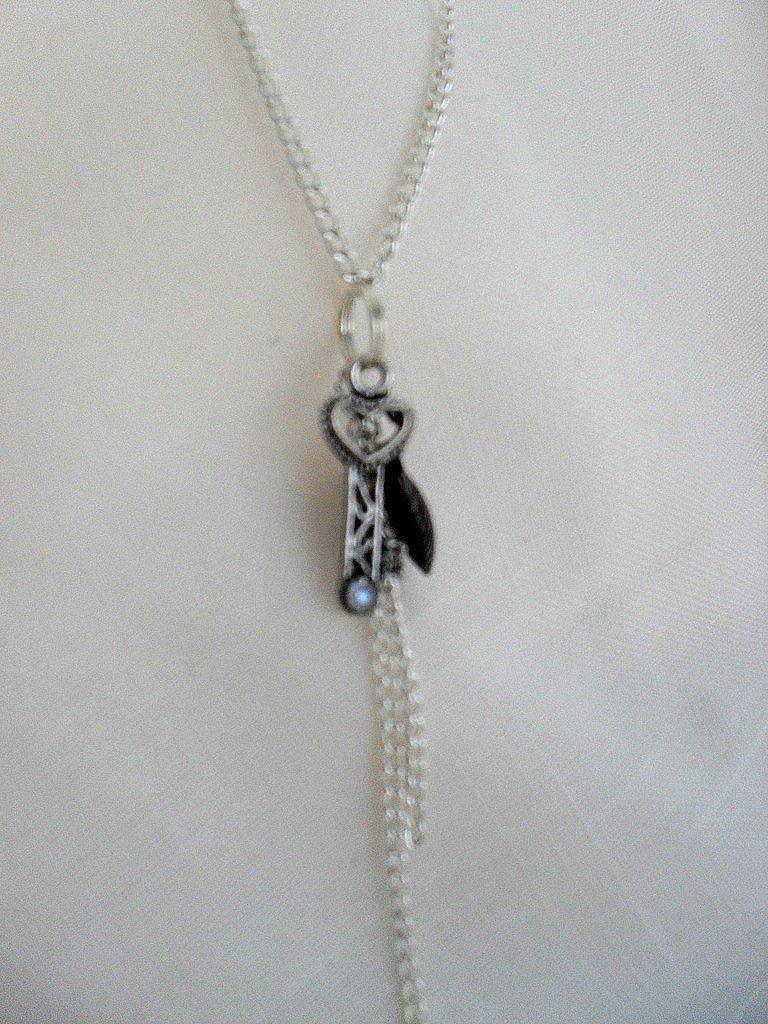Describe this image in one or two sentences. In this image we can see a chain on a cloth. 